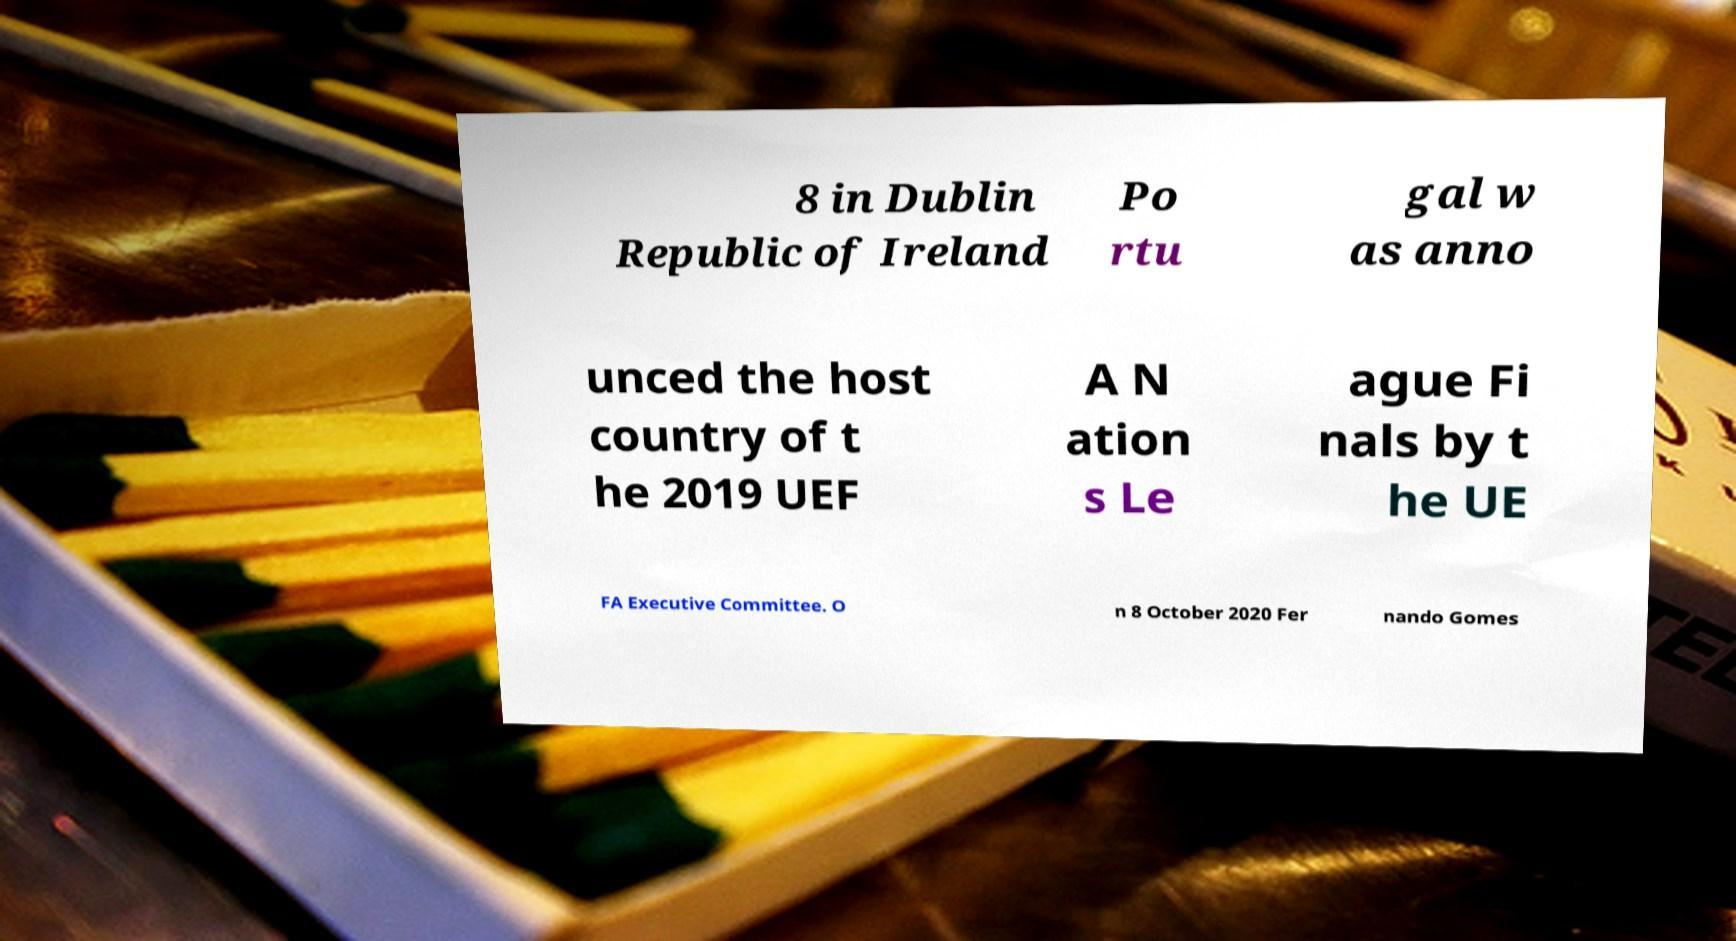Can you read and provide the text displayed in the image?This photo seems to have some interesting text. Can you extract and type it out for me? 8 in Dublin Republic of Ireland Po rtu gal w as anno unced the host country of t he 2019 UEF A N ation s Le ague Fi nals by t he UE FA Executive Committee. O n 8 October 2020 Fer nando Gomes 